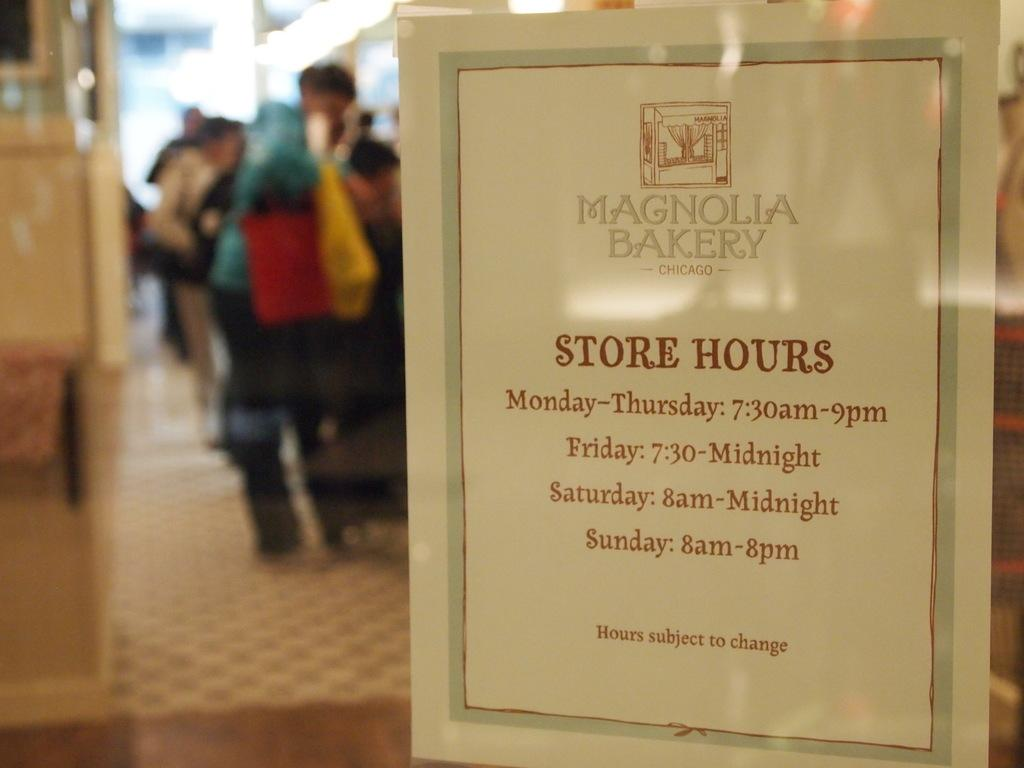<image>
Describe the image concisely. A sign for Magnolia Bakery lists the store hours. 